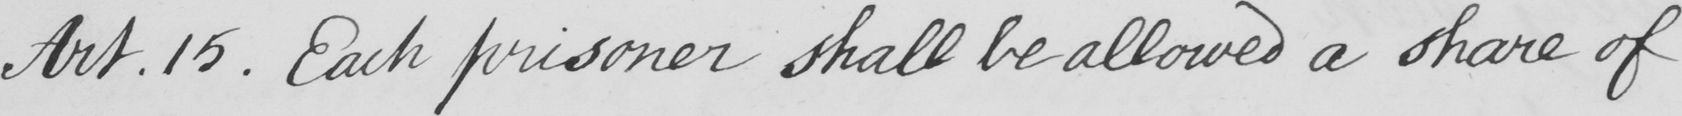Can you read and transcribe this handwriting? Art . 15 . Each prisoner shall be allowed a share of 